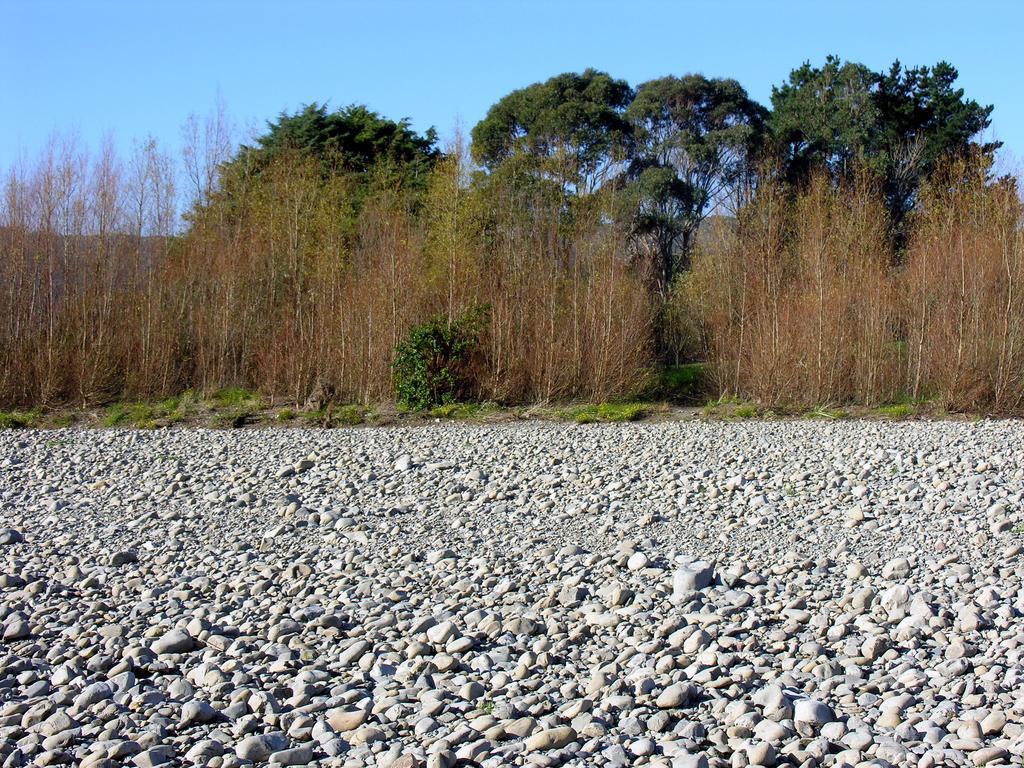Please provide a concise description of this image. In this image there are stones, grass, plants, trees, and in the background there is sky. 